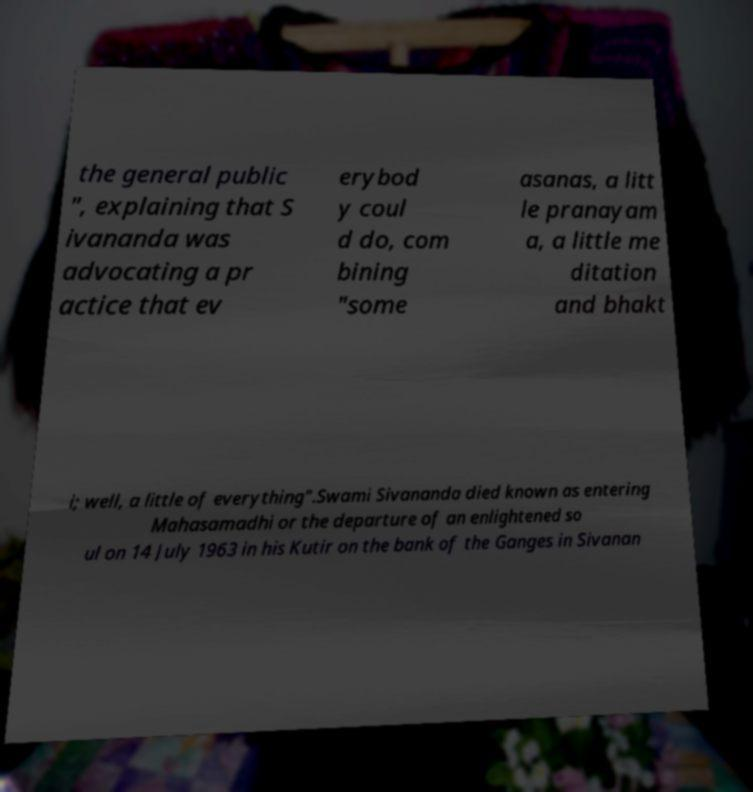Could you extract and type out the text from this image? the general public ", explaining that S ivananda was advocating a pr actice that ev erybod y coul d do, com bining "some asanas, a litt le pranayam a, a little me ditation and bhakt i; well, a little of everything".Swami Sivananda died known as entering Mahasamadhi or the departure of an enlightened so ul on 14 July 1963 in his Kutir on the bank of the Ganges in Sivanan 